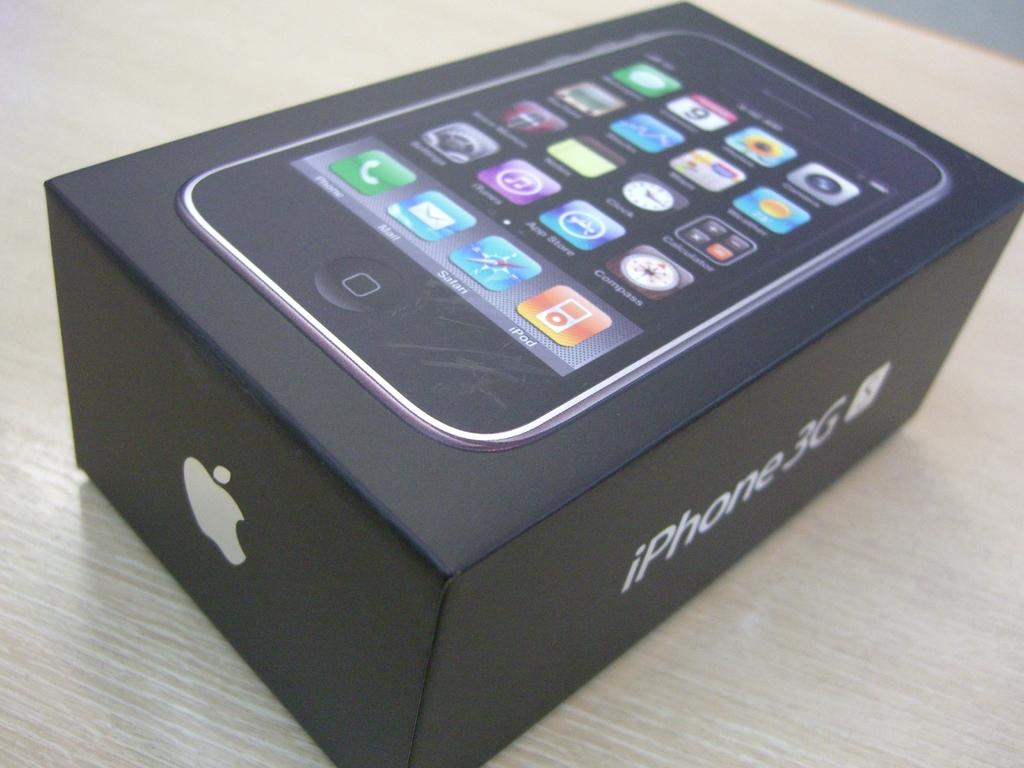What brand of phone is seen here?
Keep it short and to the point. Iphone. 